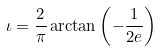Convert formula to latex. <formula><loc_0><loc_0><loc_500><loc_500>\iota = \frac { 2 } { \pi } \arctan { \left ( - \frac { 1 } { 2 e } \right ) }</formula> 